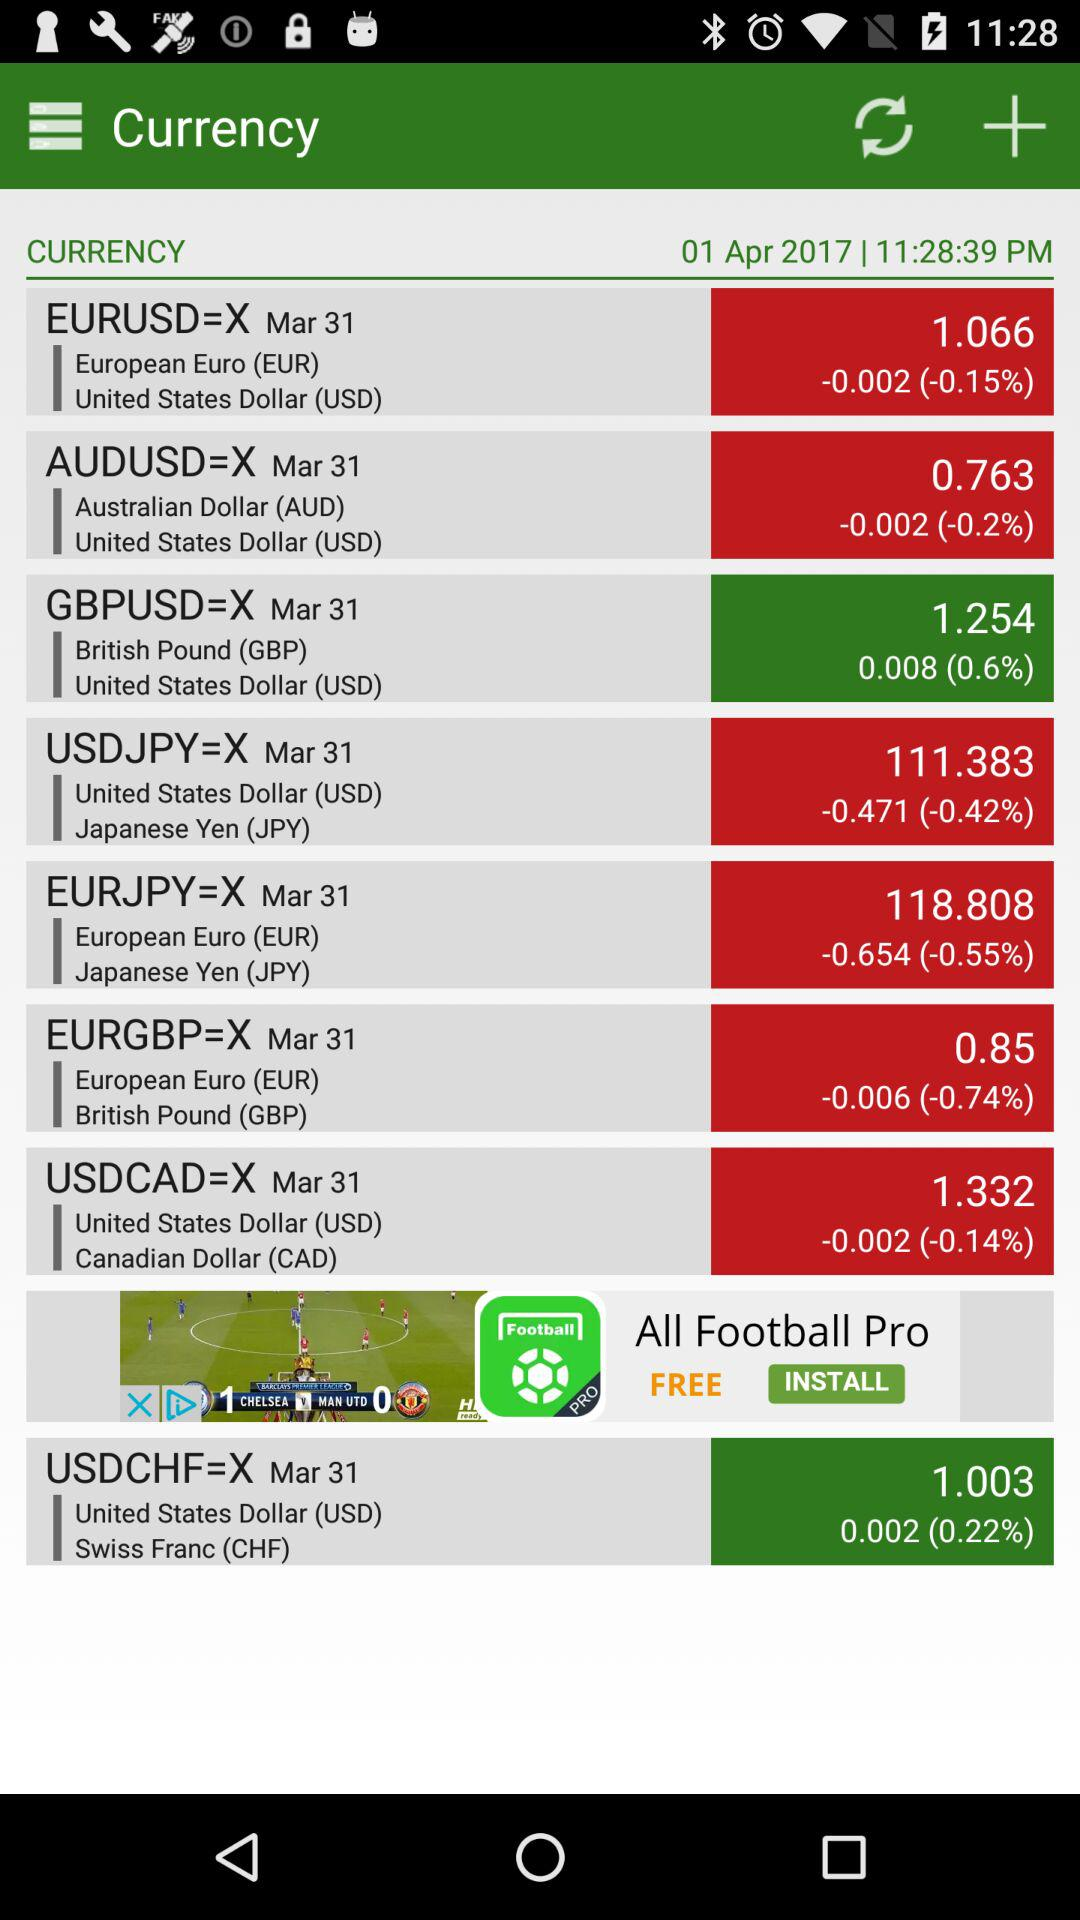What is the exchange rate of European Euro to Japanese Yen? The exchange rate is 118.808. 